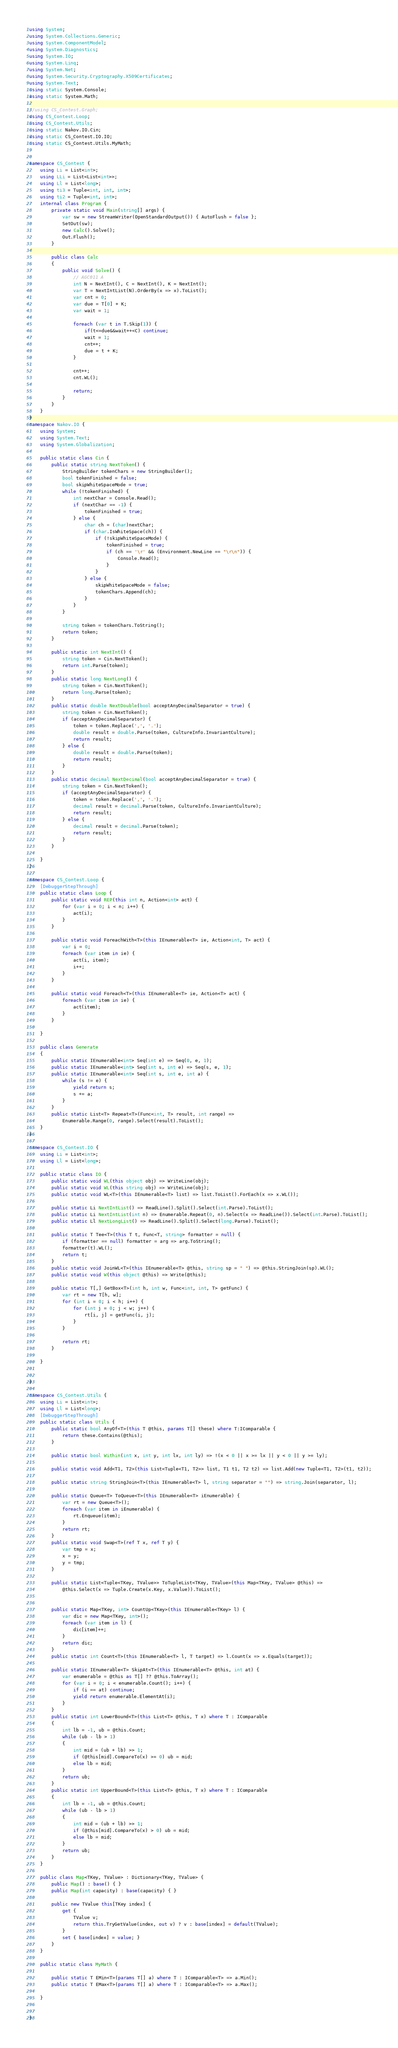<code> <loc_0><loc_0><loc_500><loc_500><_C#_>using System;
using System.Collections.Generic;
using System.ComponentModel;
using System.Diagnostics;
using System.IO;
using System.Linq;
using System.Net;
using System.Security.Cryptography.X509Certificates;
using System.Text;
using static System.Console;
using static System.Math;

//using CS_Contest.Graph;
using CS_Contest.Loop;
using CS_Contest.Utils;
using static Nakov.IO.Cin;
using static CS_Contest.IO.IO;
using static CS_Contest.Utils.MyMath;


namespace CS_Contest {
	using Li = List<int>;
	using LLi = List<List<int>>;
	using Ll = List<long>;
	using ti3 = Tuple<int, int, int>;
	using ti2 = Tuple<int, int>;
	internal class Program {
		private static void Main(string[] args) {
			var sw = new StreamWriter(OpenStandardOutput()) { AutoFlush = false };
			SetOut(sw);
			new Calc().Solve();
			Out.Flush();
		}

	    public class Calc
	    {
	        public void Solve() {
	            // AGC011 A
	            int N = NextInt(), C = NextInt(), K = NextInt();
	            var T = NextIntList(N).OrderBy(x => x).ToList();
	            var cnt = 0;
	            var due = T[0] + K;
	            var wait = 1;

	            foreach (var t in T.Skip(1)) {
	                if(t<=due&&wait++<C) continue;
	                wait = 1;
	                cnt++;
	                due = t + K;
	            }

	            cnt++;
                cnt.WL();

	            return;
	        }
	    }
	}
}
namespace Nakov.IO {
	using System;
	using System.Text;
	using System.Globalization;

	public static class Cin {
		public static string NextToken() {
			StringBuilder tokenChars = new StringBuilder();
			bool tokenFinished = false;
			bool skipWhiteSpaceMode = true;
			while (!tokenFinished) {
				int nextChar = Console.Read();
				if (nextChar == -1) {
					tokenFinished = true;
				} else {
					char ch = (char)nextChar;
					if (char.IsWhiteSpace(ch)) {
						if (!skipWhiteSpaceMode) {
							tokenFinished = true;
							if (ch == '\r' && (Environment.NewLine == "\r\n")) {
								Console.Read();
							}
						}
					} else {
						skipWhiteSpaceMode = false;
						tokenChars.Append(ch);
					}
				}
			}

			string token = tokenChars.ToString();
			return token;
		}

		public static int NextInt() {
			string token = Cin.NextToken();
			return int.Parse(token);
		}
		public static long NextLong() {
			string token = Cin.NextToken();
			return long.Parse(token);
		}
		public static double NextDouble(bool acceptAnyDecimalSeparator = true) {
			string token = Cin.NextToken();
			if (acceptAnyDecimalSeparator) {
				token = token.Replace(',', '.');
				double result = double.Parse(token, CultureInfo.InvariantCulture);
				return result;
			} else {
				double result = double.Parse(token);
				return result;
			}
		}
		public static decimal NextDecimal(bool acceptAnyDecimalSeparator = true) {
			string token = Cin.NextToken();
			if (acceptAnyDecimalSeparator) {
				token = token.Replace(',', '.');
				decimal result = decimal.Parse(token, CultureInfo.InvariantCulture);
				return result;
			} else {
				decimal result = decimal.Parse(token);
				return result;
			}
		}

	}
}

namespace CS_Contest.Loop {
	[DebuggerStepThrough]
	public static class Loop {
		public static void REP(this int n, Action<int> act) {
			for (var i = 0; i < n; i++) {
				act(i);
			}
		}

		public static void ForeachWith<T>(this IEnumerable<T> ie, Action<int, T> act) {
			var i = 0;
			foreach (var item in ie) {
				act(i, item);
				i++;
			}
		}

		public static void Foreach<T>(this IEnumerable<T> ie, Action<T> act) {
			foreach (var item in ie) {
				act(item);
			}
		}

	}

	public class Generate
	{
	    public static IEnumerable<int> Seq(int e) => Seq(0, e, 1);
		public static IEnumerable<int> Seq(int s, int e) => Seq(s, e, 1);
		public static IEnumerable<int> Seq(int s, int e, int a) {
			while (s != e) {
				yield return s;
				s += a;
			}
		}
		public static List<T> Repeat<T>(Func<int, T> result, int range) =>
			Enumerable.Range(0, range).Select(result).ToList();
	}
}

namespace CS_Contest.IO {
	using Li = List<int>;
	using Ll = List<long>;

	public static class IO {
		public static void WL(this object obj) => WriteLine(obj);
		public static void WL(this string obj) => WriteLine(obj);
		public static void WL<T>(this IEnumerable<T> list) => list.ToList().ForEach(x => x.WL());

		public static Li NextIntList() => ReadLine().Split().Select(int.Parse).ToList();
		public static Li NextIntList(int n) => Enumerable.Repeat(0, n).Select(x => ReadLine()).Select(int.Parse).ToList();
		public static Ll NextLongList() => ReadLine().Split().Select(long.Parse).ToList();

		public static T Tee<T>(this T t, Func<T, string> formatter = null) {
			if (formatter == null) formatter = arg => arg.ToString();
			formatter(t).WL();
			return t;
		}
		public static void JoinWL<T>(this IEnumerable<T> @this, string sp = " ") => @this.StringJoin(sp).WL();
		public static void W(this object @this) => Write(@this);

	    public static T[,] GetBox<T>(int h, int w, Func<int, int, T> getFunc) {
	        var rt = new T[h, w];
	        for (int i = 0; i < h; i++) {
	            for (int j = 0; j < w; j++) {
	                rt[i, j] = getFunc(i, j);
	            }
	        }

	        return rt;
	    }

	}


}

namespace CS_Contest.Utils {
	using Li = List<int>;
	using Ll = List<long>;
	[DebuggerStepThrough]
	public static class Utils {
	    public static bool AnyOf<T>(this T @this, params T[] these) where T:IComparable {
	        return these.Contains(@this);
	    }

		public static bool Within(int x, int y, int lx, int ly) => !(x < 0 || x >= lx || y < 0 || y >= ly);

		public static void Add<T1, T2>(this List<Tuple<T1, T2>> list, T1 t1, T2 t2) => list.Add(new Tuple<T1, T2>(t1, t2));

		public static string StringJoin<T>(this IEnumerable<T> l, string separator = "") => string.Join(separator, l);

		public static Queue<T> ToQueue<T>(this IEnumerable<T> iEnumerable) {
			var rt = new Queue<T>();
			foreach (var item in iEnumerable) {
				rt.Enqueue(item);
			}
			return rt;
		}
		public static void Swap<T>(ref T x, ref T y) {
			var tmp = x;
			x = y;
			y = tmp;
		}

	    public static List<Tuple<TKey, TValue>> ToTupleList<TKey, TValue>(this Map<TKey, TValue> @this) =>
	        @this.Select(x => Tuple.Create(x.Key, x.Value)).ToList();


		public static Map<TKey, int> CountUp<TKey>(this IEnumerable<TKey> l) {
			var dic = new Map<TKey, int>();
			foreach (var item in l) {
			    dic[item]++;
			}
			return dic;
		}
		public static int Count<T>(this IEnumerable<T> l, T target) => l.Count(x => x.Equals(target));

		public static IEnumerable<T> SkipAt<T>(this IEnumerable<T> @this, int at) {
			var enumerable = @this as T[] ?? @this.ToArray();
			for (var i = 0; i < enumerable.Count(); i++) {
				if (i == at) continue;
				yield return enumerable.ElementAt(i);
			}
		}
	    public static int LowerBound<T>(this List<T> @this, T x) where T : IComparable
	    {
            int lb = -1, ub = @this.Count;
	        while (ub - lb > 1)
	        {
	            int mid = (ub + lb) >> 1;
	            if (@this[mid].CompareTo(x) >= 0) ub = mid;
	            else lb = mid;
	        }
	        return ub;
	    }
	    public static int UpperBound<T>(this List<T> @this, T x) where T : IComparable
	    {
	        int lb = -1, ub = @this.Count;
	        while (ub - lb > 1)
	        {
	            int mid = (ub + lb) >> 1;
	            if (@this[mid].CompareTo(x) > 0) ub = mid;
	            else lb = mid;
	        }
	        return ub;
	    }
    }

	public class Map<TKey, TValue> : Dictionary<TKey, TValue> {
		public Map() : base() { }
		public Map(int capacity) : base(capacity) { }

		public new TValue this[TKey index] {
			get {
				TValue v;
				return this.TryGetValue(index, out v) ? v : base[index] = default(TValue);
			}
			set { base[index] = value; }
		}
	}

	public static class MyMath {
		
		public static T EMin<T>(params T[] a) where T : IComparable<T> => a.Min();
		public static T EMax<T>(params T[] a) where T : IComparable<T> => a.Max();

	}


}

</code> 